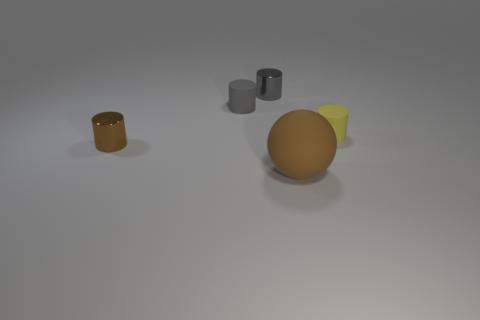If these objects were part of a still life composition, what themes could they represent? If treated as a still life, these objects could convey themes of harmony and balance through their simple geometry and composition. The different shapes — cylindrical, spherical, and wedge — offer a study of form and space. The subdued palette might suggest themes of unity or uniformity, inviting contemplation on the interplay between light, shadow, and form. Such a composition could evoke thoughts on the fundamentals of visual arts or the beauty of simplicity in design. 